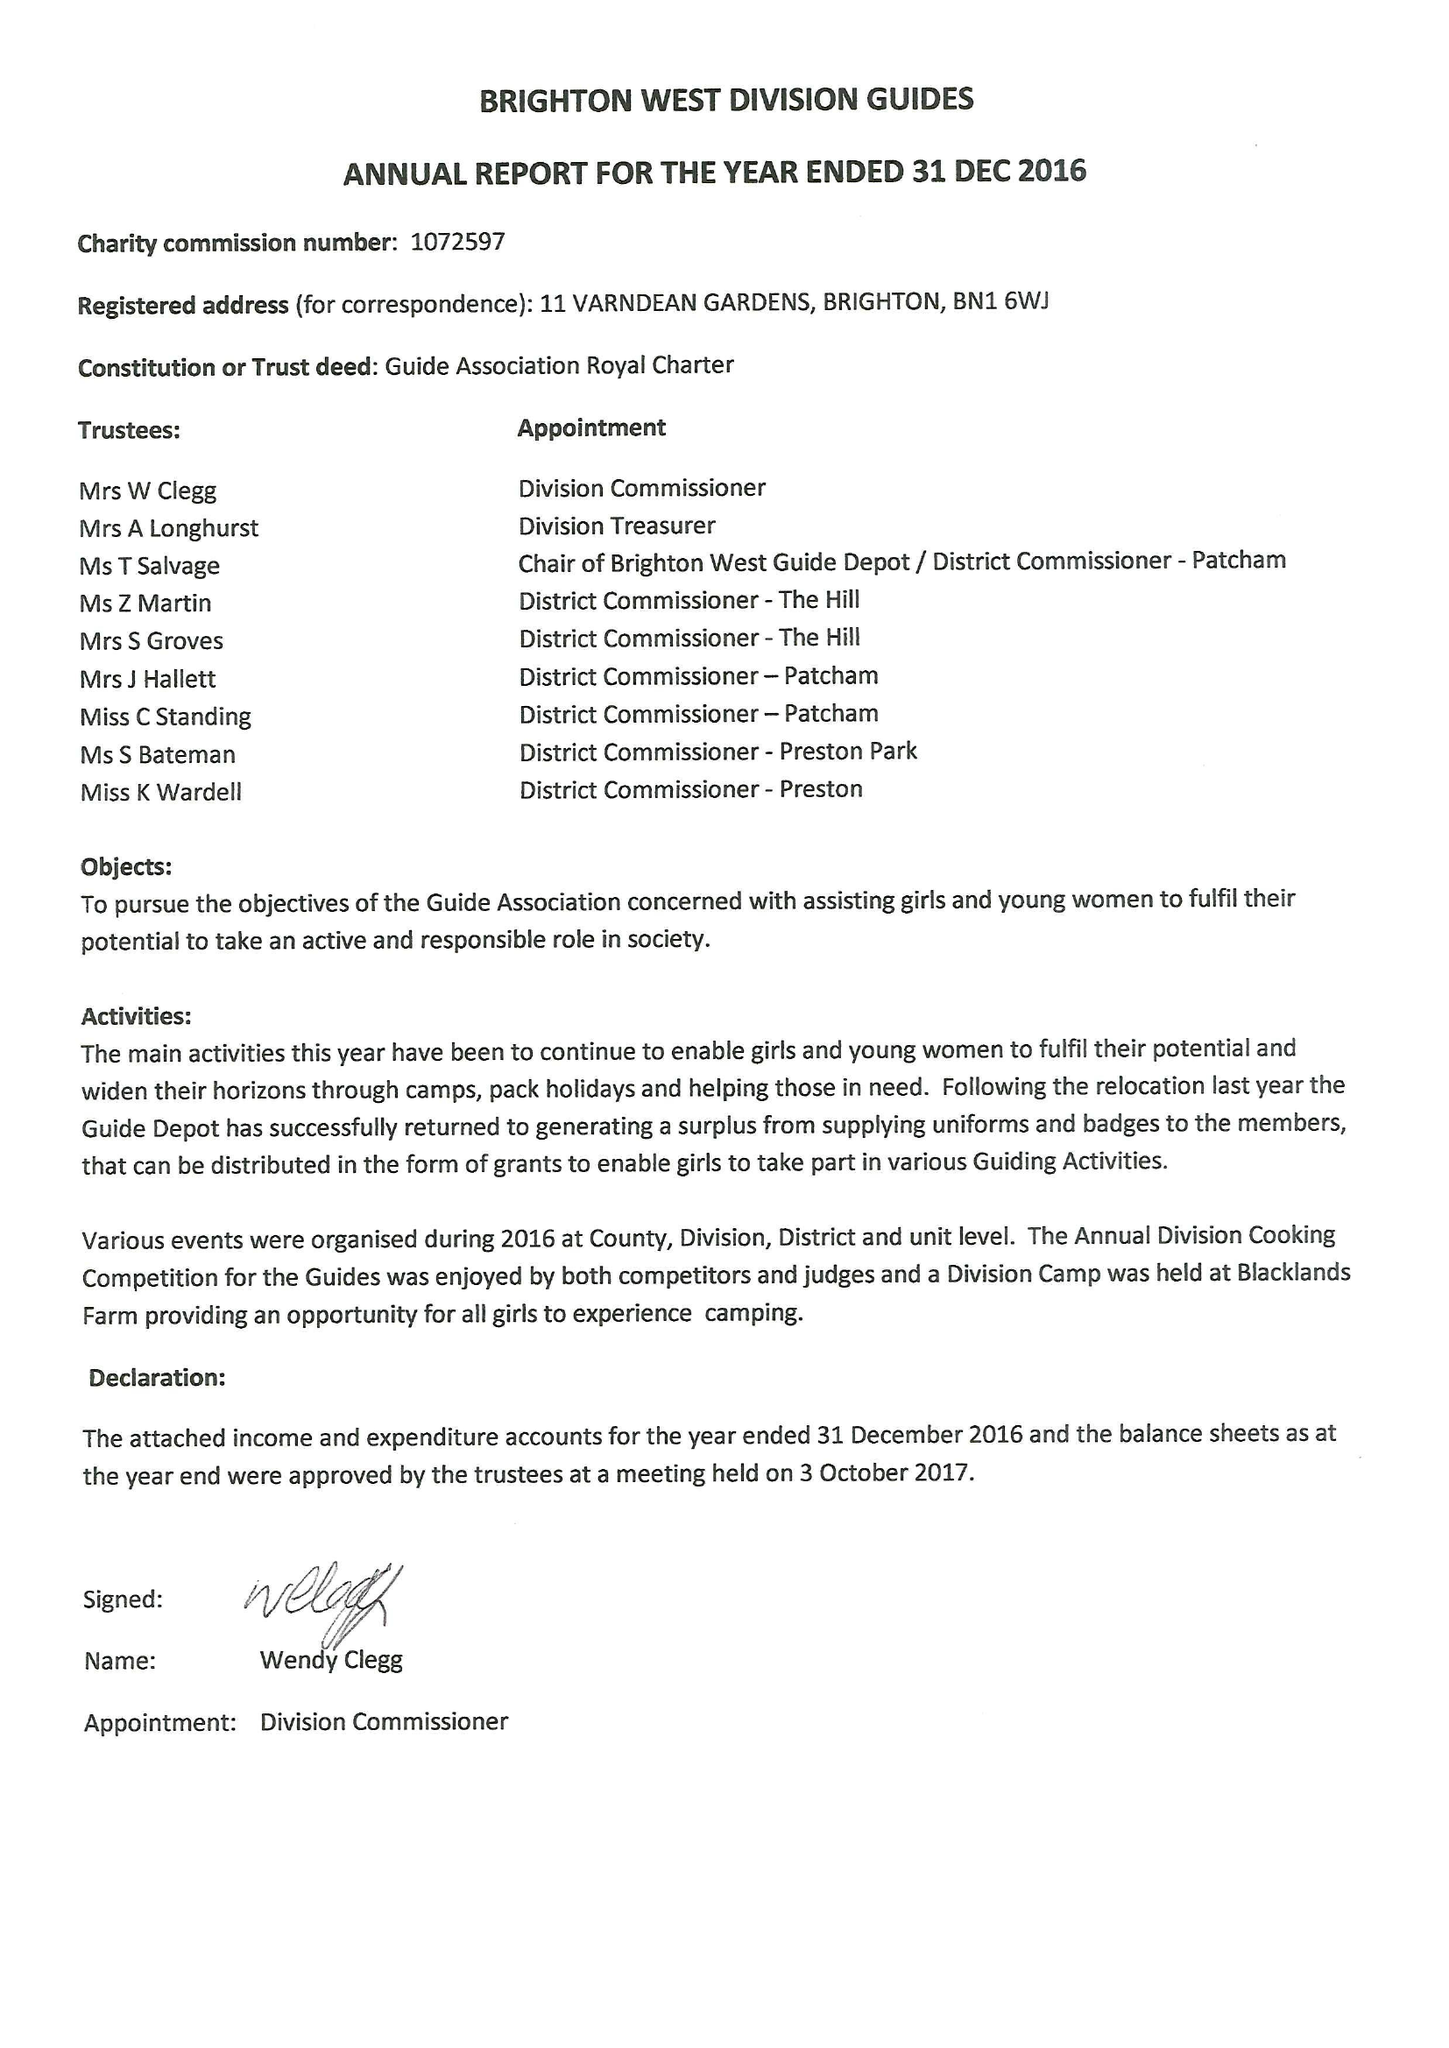What is the value for the report_date?
Answer the question using a single word or phrase. 2016-12-31 